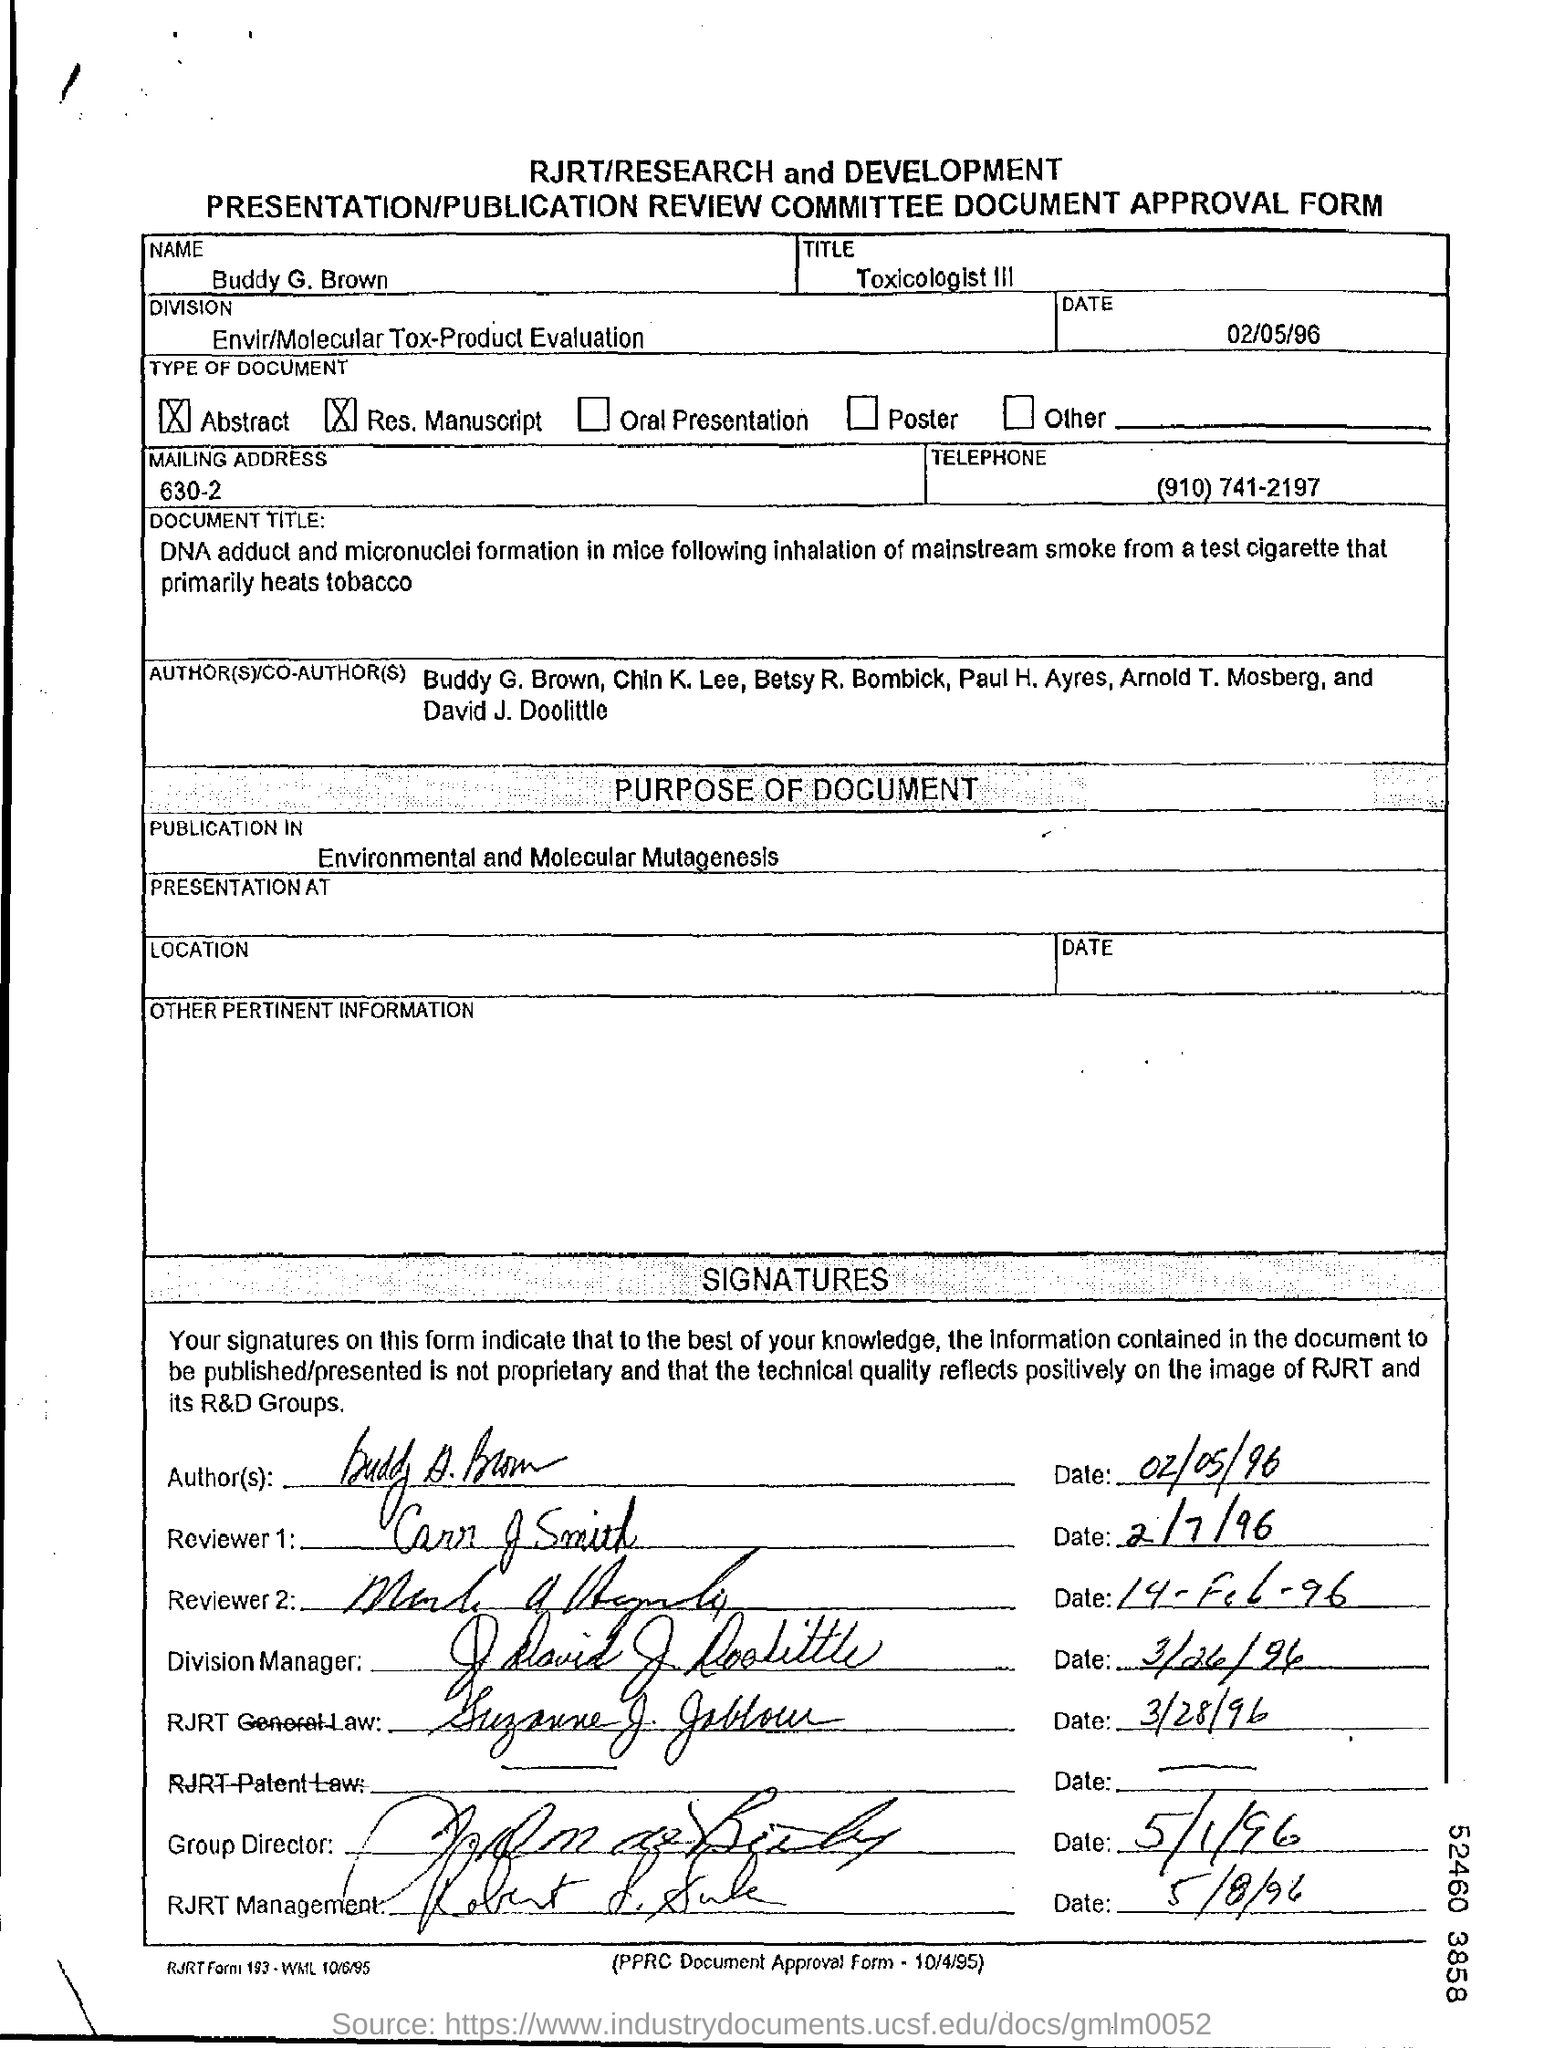What is the name given?
Your answer should be compact. Buddy G. Brown. What is Buddy's title?
Ensure brevity in your answer.  Toxicologist III. Which division is mentioned?
Offer a very short reply. Envir/Molecular Tox-Product Evaluation. When is the form dated?
Make the answer very short. 02/05/96. Where was the document published?
Offer a terse response. Environmental and Molecular Mutagenesis. 